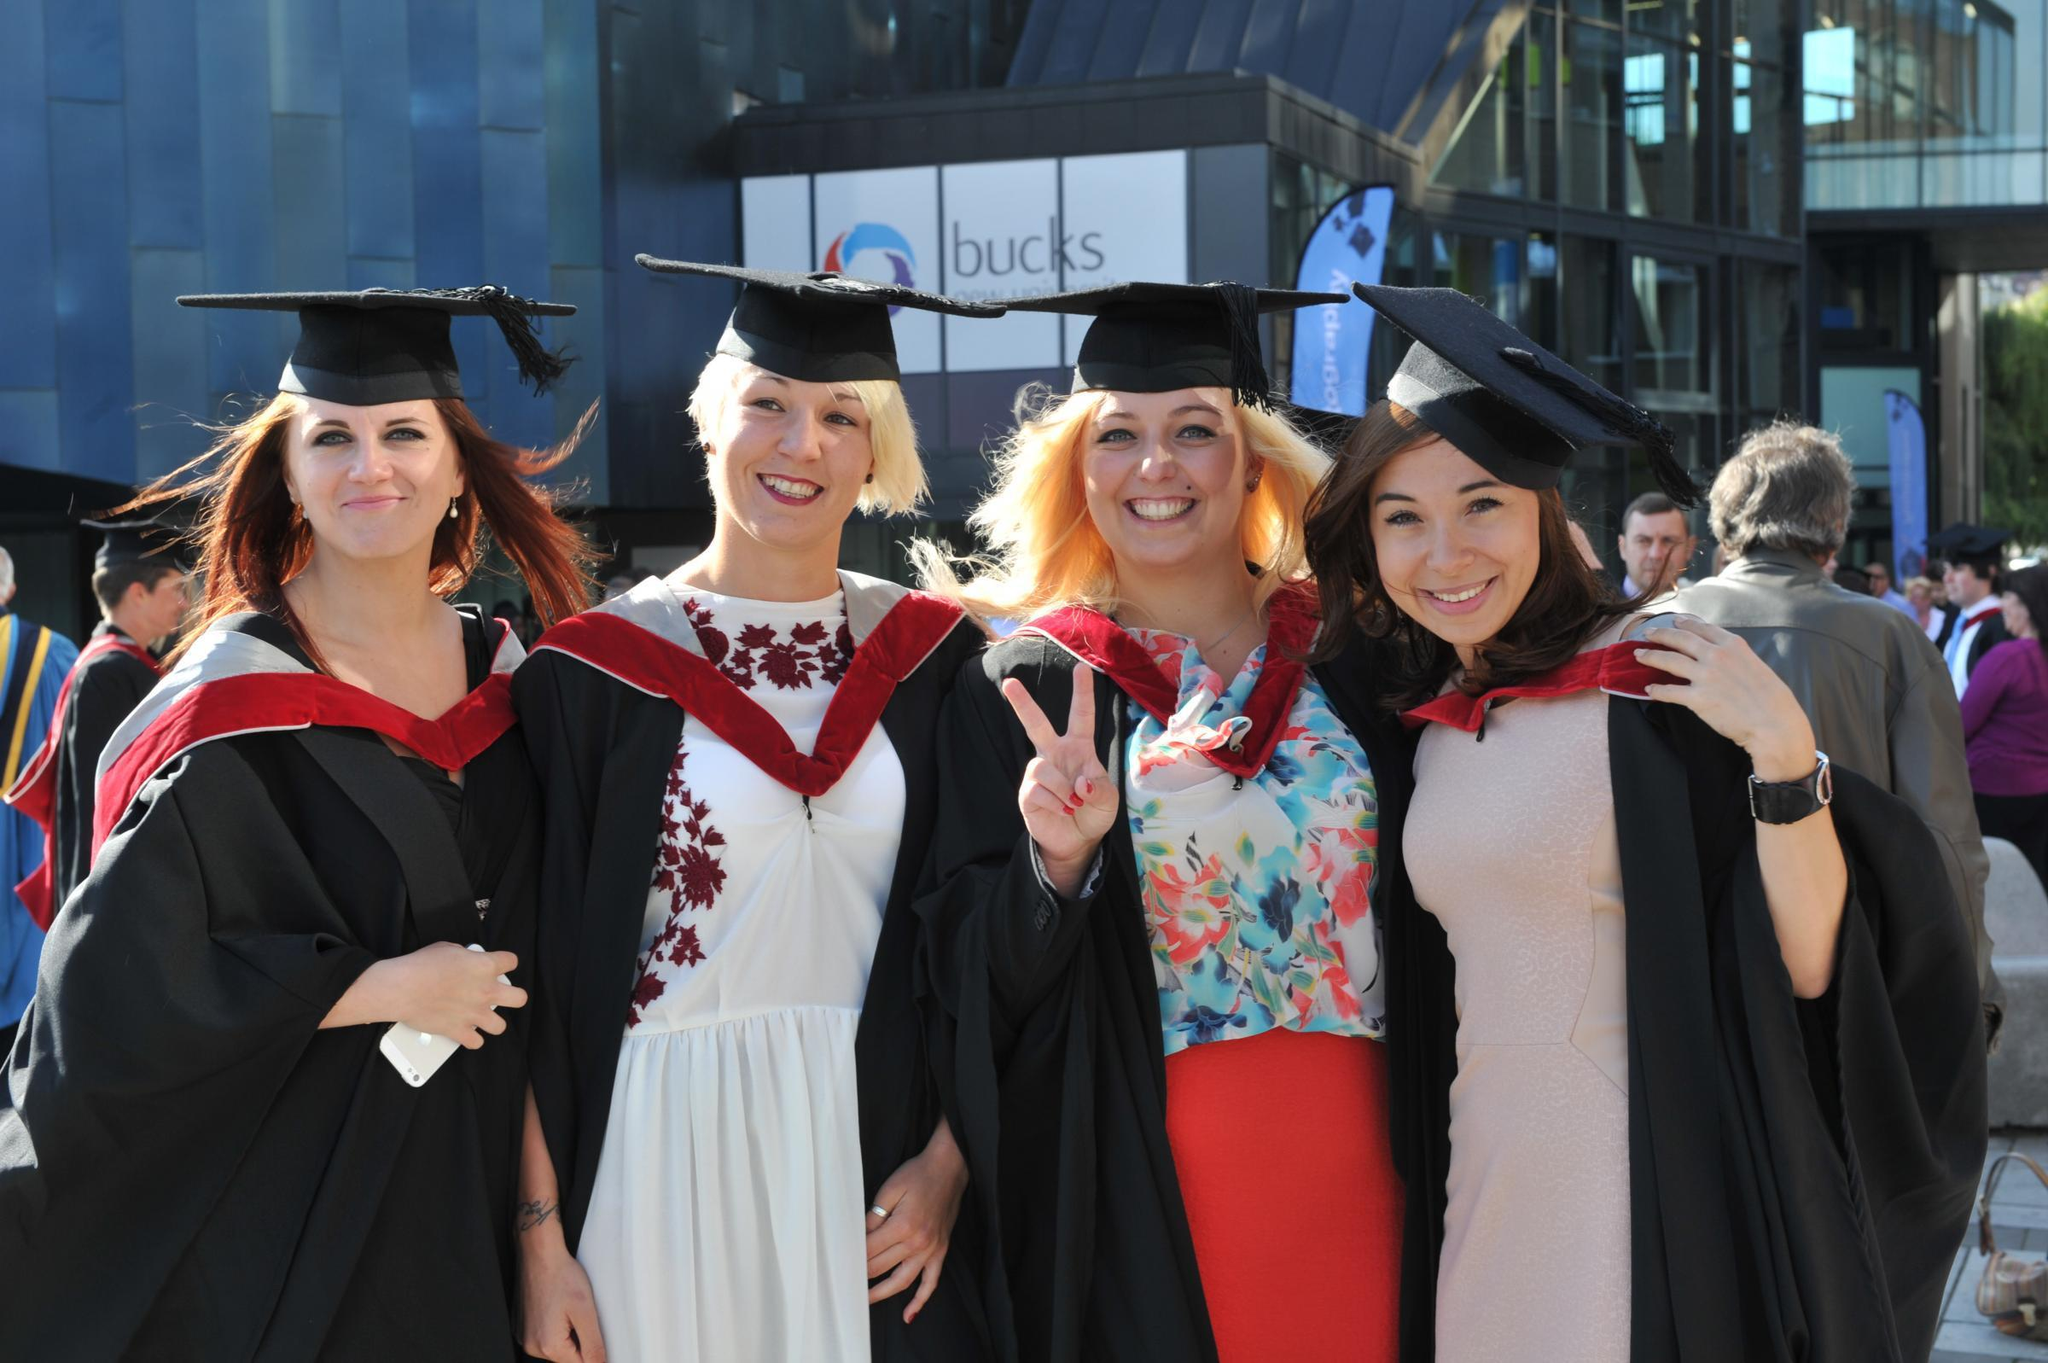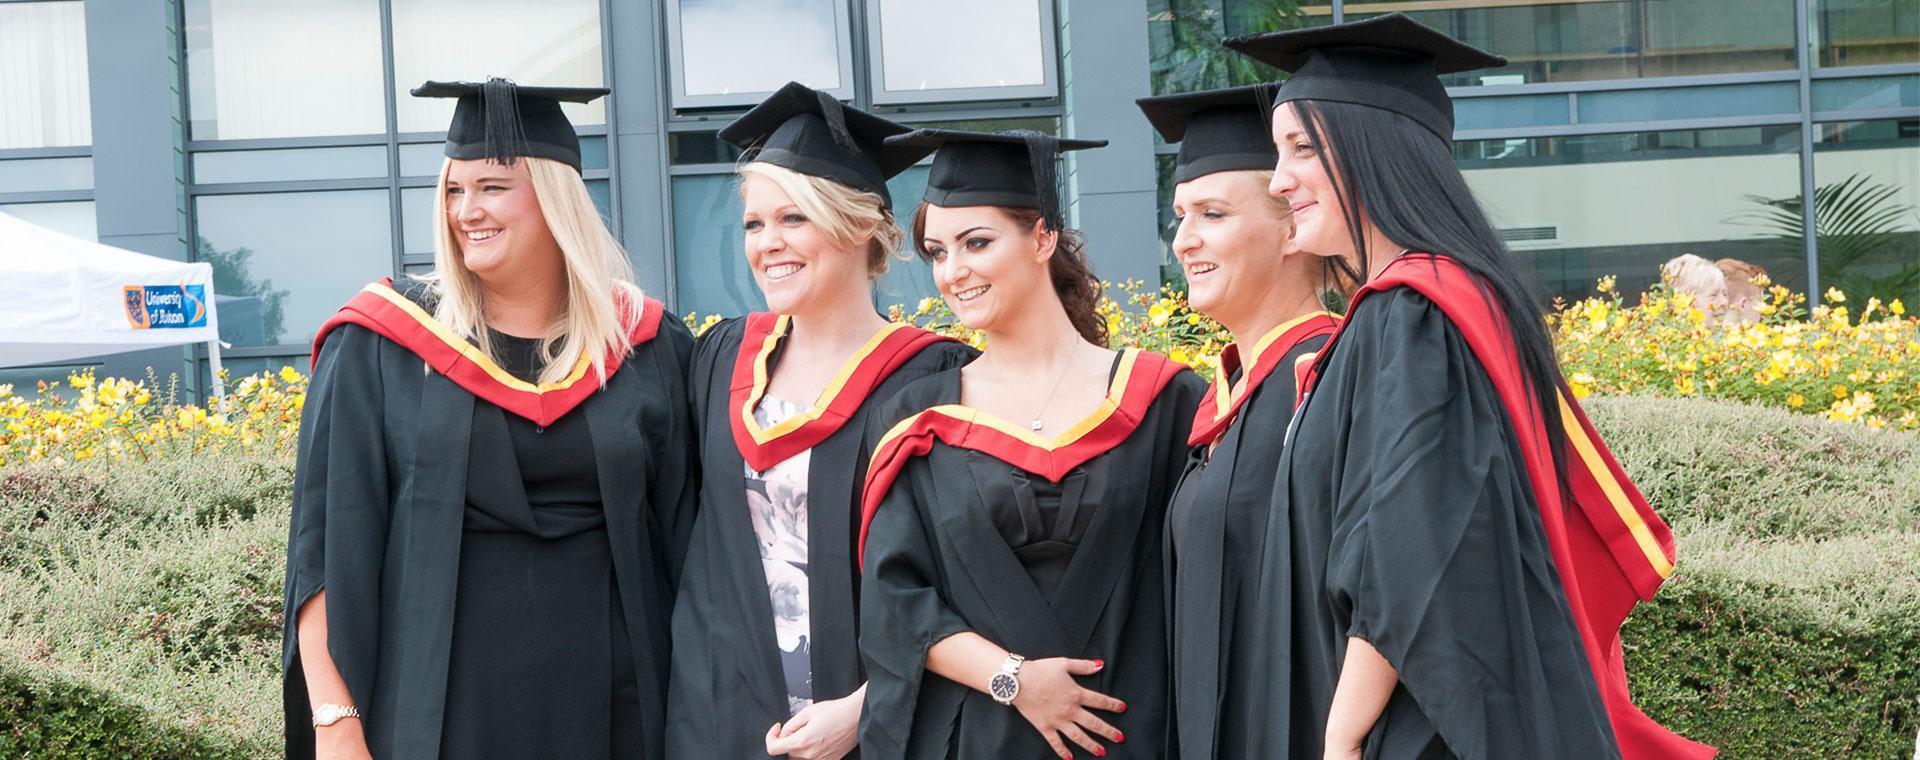The first image is the image on the left, the second image is the image on the right. Given the left and right images, does the statement "The left image shows a group of four people." hold true? Answer yes or no. Yes. 